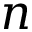Convert formula to latex. <formula><loc_0><loc_0><loc_500><loc_500>n</formula> 